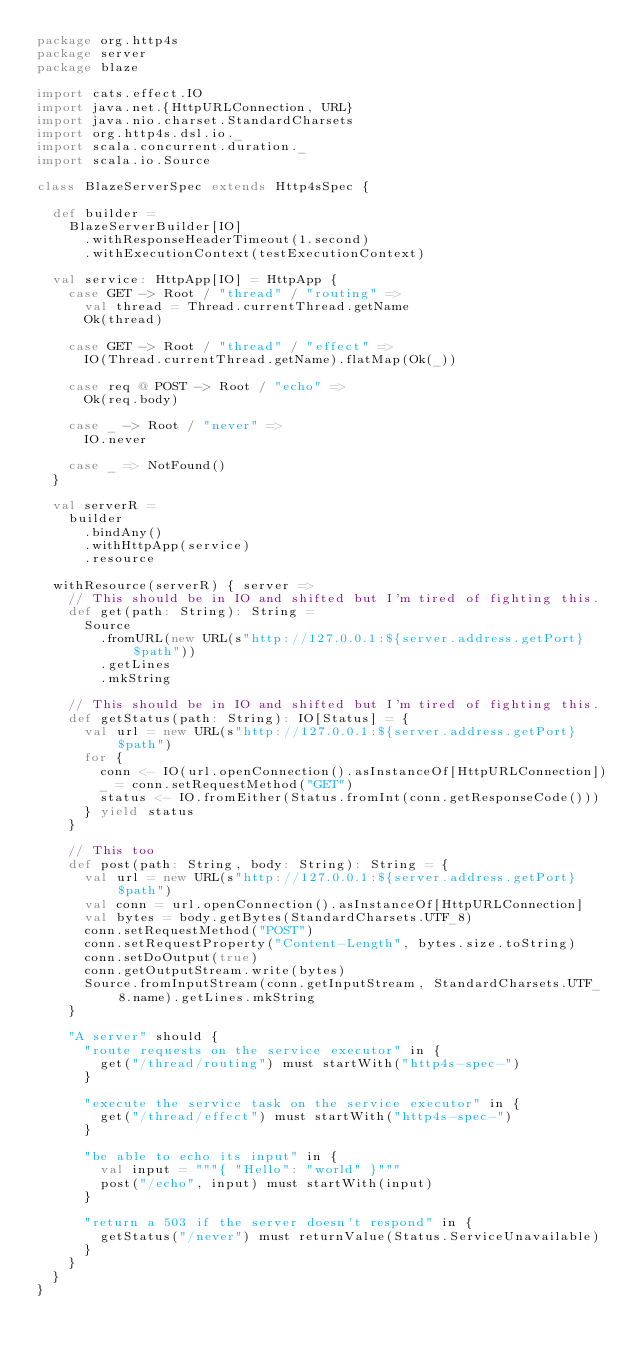Convert code to text. <code><loc_0><loc_0><loc_500><loc_500><_Scala_>package org.http4s
package server
package blaze

import cats.effect.IO
import java.net.{HttpURLConnection, URL}
import java.nio.charset.StandardCharsets
import org.http4s.dsl.io._
import scala.concurrent.duration._
import scala.io.Source

class BlazeServerSpec extends Http4sSpec {

  def builder =
    BlazeServerBuilder[IO]
      .withResponseHeaderTimeout(1.second)
      .withExecutionContext(testExecutionContext)

  val service: HttpApp[IO] = HttpApp {
    case GET -> Root / "thread" / "routing" =>
      val thread = Thread.currentThread.getName
      Ok(thread)

    case GET -> Root / "thread" / "effect" =>
      IO(Thread.currentThread.getName).flatMap(Ok(_))

    case req @ POST -> Root / "echo" =>
      Ok(req.body)

    case _ -> Root / "never" =>
      IO.never

    case _ => NotFound()
  }

  val serverR =
    builder
      .bindAny()
      .withHttpApp(service)
      .resource

  withResource(serverR) { server =>
    // This should be in IO and shifted but I'm tired of fighting this.
    def get(path: String): String =
      Source
        .fromURL(new URL(s"http://127.0.0.1:${server.address.getPort}$path"))
        .getLines
        .mkString

    // This should be in IO and shifted but I'm tired of fighting this.
    def getStatus(path: String): IO[Status] = {
      val url = new URL(s"http://127.0.0.1:${server.address.getPort}$path")
      for {
        conn <- IO(url.openConnection().asInstanceOf[HttpURLConnection])
        _ = conn.setRequestMethod("GET")
        status <- IO.fromEither(Status.fromInt(conn.getResponseCode()))
      } yield status
    }

    // This too
    def post(path: String, body: String): String = {
      val url = new URL(s"http://127.0.0.1:${server.address.getPort}$path")
      val conn = url.openConnection().asInstanceOf[HttpURLConnection]
      val bytes = body.getBytes(StandardCharsets.UTF_8)
      conn.setRequestMethod("POST")
      conn.setRequestProperty("Content-Length", bytes.size.toString)
      conn.setDoOutput(true)
      conn.getOutputStream.write(bytes)
      Source.fromInputStream(conn.getInputStream, StandardCharsets.UTF_8.name).getLines.mkString
    }

    "A server" should {
      "route requests on the service executor" in {
        get("/thread/routing") must startWith("http4s-spec-")
      }

      "execute the service task on the service executor" in {
        get("/thread/effect") must startWith("http4s-spec-")
      }

      "be able to echo its input" in {
        val input = """{ "Hello": "world" }"""
        post("/echo", input) must startWith(input)
      }

      "return a 503 if the server doesn't respond" in {
        getStatus("/never") must returnValue(Status.ServiceUnavailable)
      }
    }
  }
}
</code> 